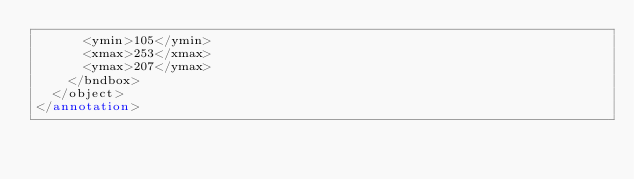<code> <loc_0><loc_0><loc_500><loc_500><_XML_>			<ymin>105</ymin>
			<xmax>253</xmax>
			<ymax>207</ymax>
		</bndbox>
	</object>
</annotation>
</code> 